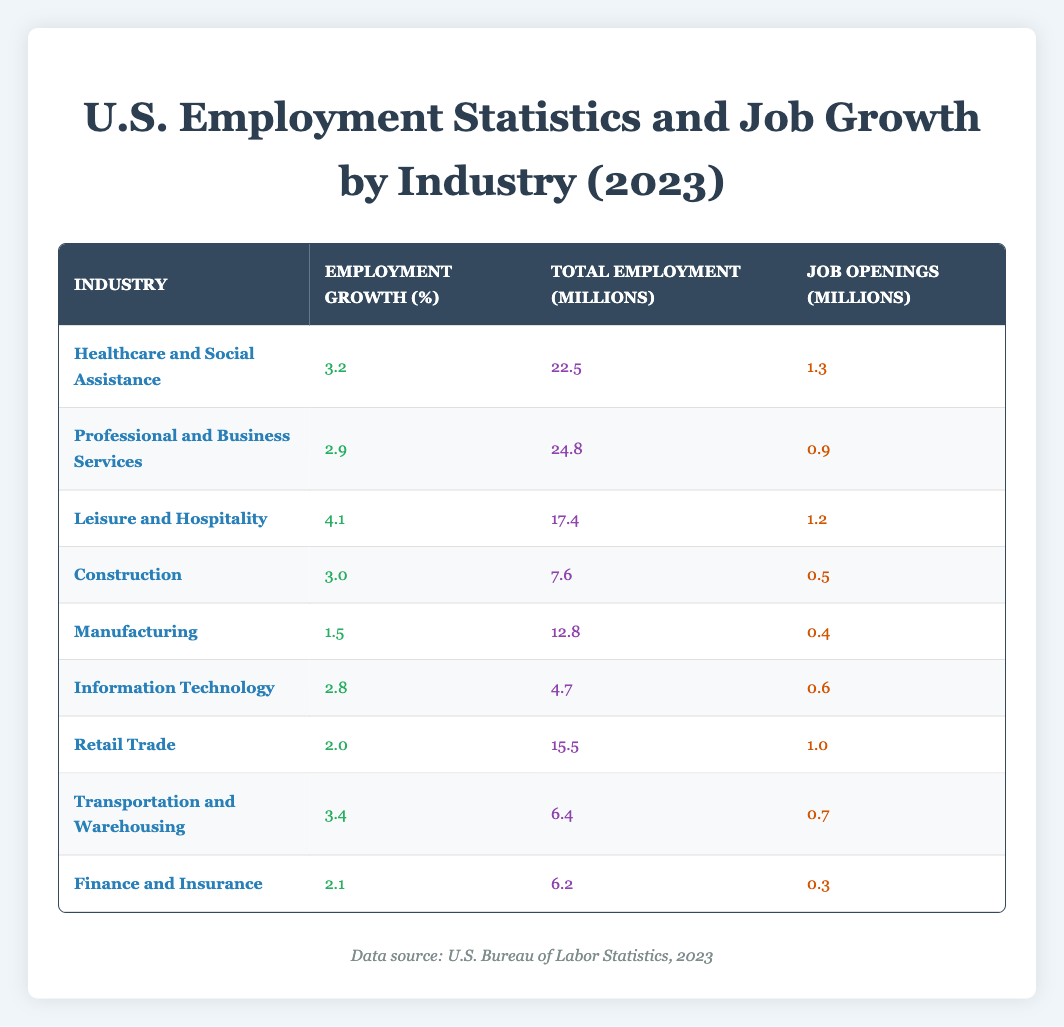What industry has the highest employment growth in 2023? By examining the Employment Growth column, I see that the highest percentage is 4.1, which corresponds to the Leisure and Hospitality industry.
Answer: Leisure and Hospitality What is the total employment in the Healthcare and Social Assistance industry? Looking at the Total Employment column for Healthcare and Social Assistance, the value is 22.5 million.
Answer: 22.5 million Are there more job openings in Construction than in Finance and Insurance? For Construction, the Job Openings value is 0.5 million, while for Finance and Insurance, it is 0.3 million. Since 0.5 is greater than 0.3, there are indeed more job openings in Construction.
Answer: Yes What is the average employment growth of all industries listed? To calculate the average, I first sum the Employment Growth percentages: (3.2 + 2.9 + 4.1 + 3.0 + 1.5 + 2.8 + 2.0 + 3.4 + 2.1) = 23.0. Dividing by the number of industries (9), I find the average is 23.0 / 9 ≈ 2.56.
Answer: 2.56 Which industry had the least total employment in 2023? Reviewing the Total Employment column, I find the lowest value is 4.7 million, which belongs to the Information Technology industry.
Answer: Information Technology How many job openings are present in the Professional and Business Services industry? According to the Job Openings column for Professional and Business Services, the value is 0.9 million.
Answer: 0.9 million Is the job openings in the Retail Trade industry greater than 1 million? The Job Openings value for Retail Trade is 1.0 million, which is equal to 1 million, so the answer is no.
Answer: No What is the difference in total employment between Leisure and Hospitality and Retail Trade? Total Employment for Leisure and Hospitality is 17.4 million and for Retail Trade is 15.5 million. The difference is 17.4 - 15.5 = 1.9 million.
Answer: 1.9 million 